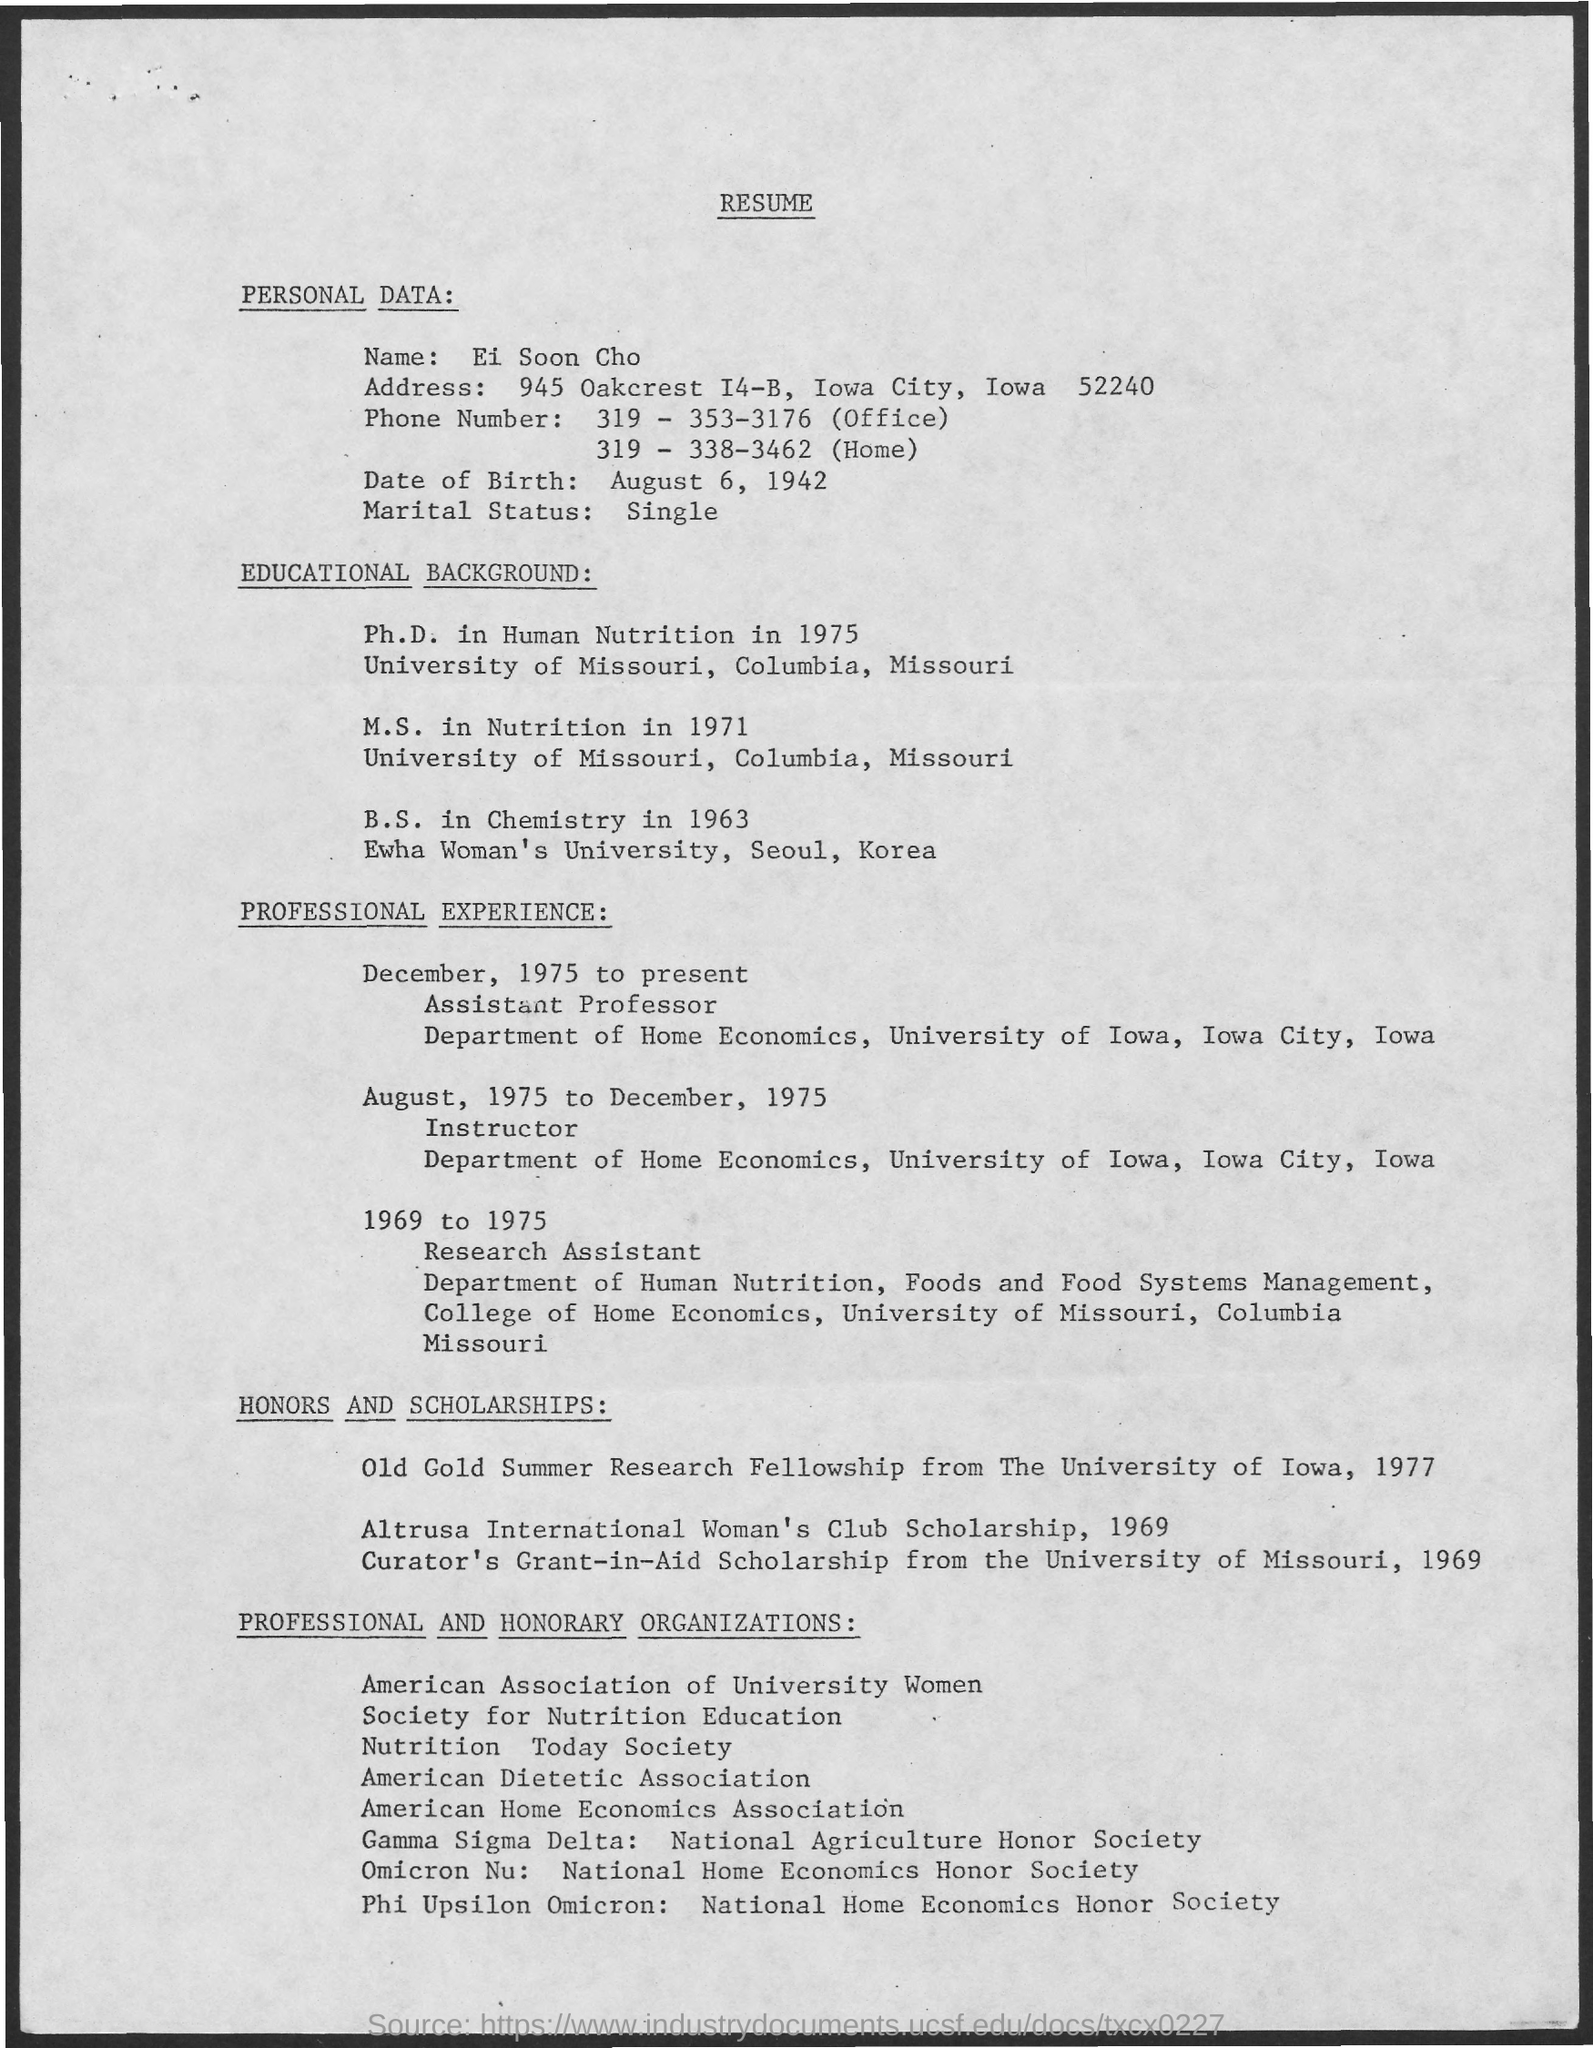Whose resume is this
Your answer should be compact. Ei Soon Cho. What is the date of birth given this resume
Your response must be concise. August 6, 1942. What is the marital status given in resume
Keep it short and to the point. Single. 